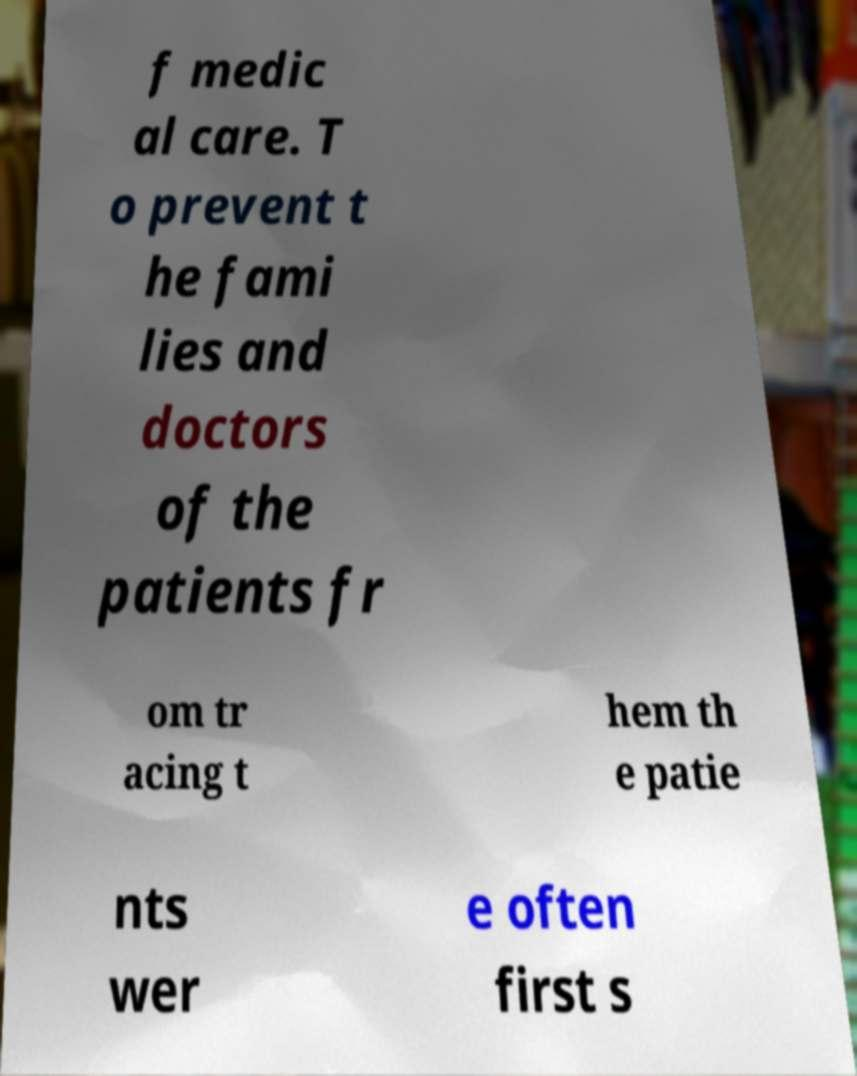Please identify and transcribe the text found in this image. f medic al care. T o prevent t he fami lies and doctors of the patients fr om tr acing t hem th e patie nts wer e often first s 